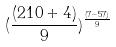<formula> <loc_0><loc_0><loc_500><loc_500>( \frac { ( 2 1 0 + 4 ) } { 9 } ) ^ { \frac { ( 7 - 5 7 ) } { 9 } }</formula> 